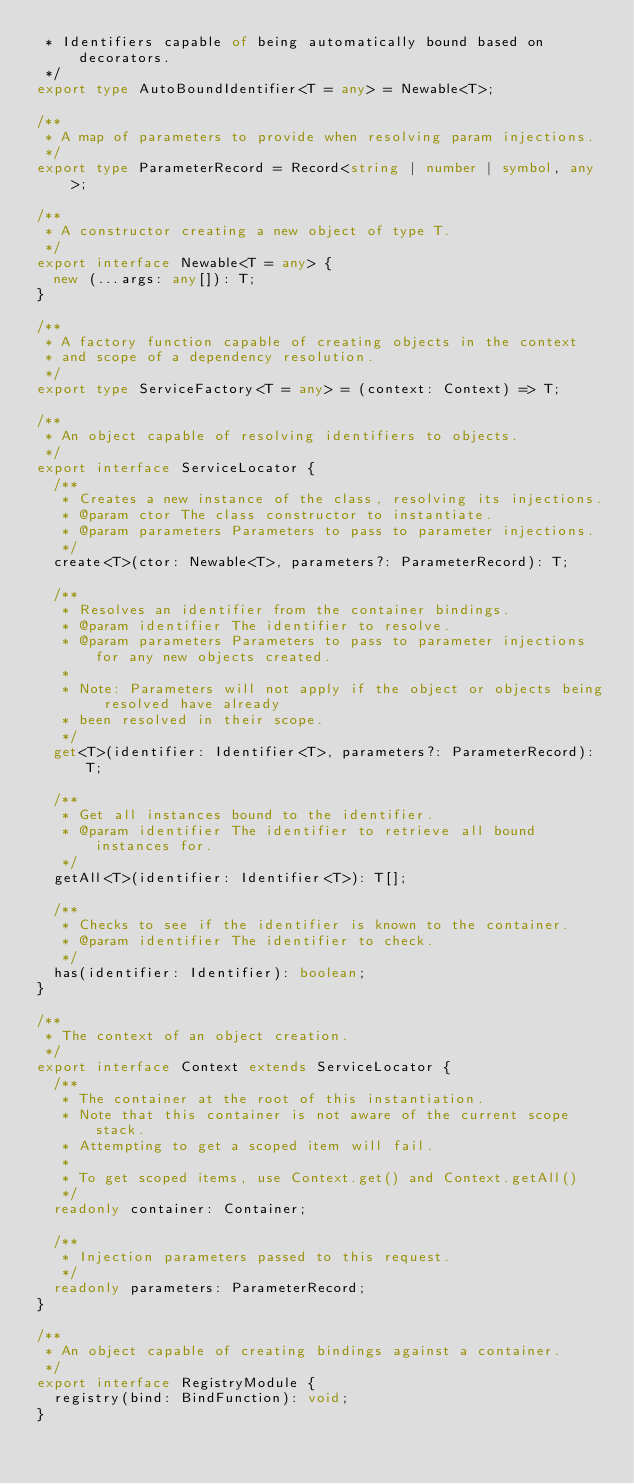<code> <loc_0><loc_0><loc_500><loc_500><_TypeScript_> * Identifiers capable of being automatically bound based on decorators.
 */
export type AutoBoundIdentifier<T = any> = Newable<T>;

/**
 * A map of parameters to provide when resolving param injections.
 */
export type ParameterRecord = Record<string | number | symbol, any>;

/**
 * A constructor creating a new object of type T.
 */
export interface Newable<T = any> {
  new (...args: any[]): T;
}

/**
 * A factory function capable of creating objects in the context
 * and scope of a dependency resolution.
 */
export type ServiceFactory<T = any> = (context: Context) => T;

/**
 * An object capable of resolving identifiers to objects.
 */
export interface ServiceLocator {
  /**
   * Creates a new instance of the class, resolving its injections.
   * @param ctor The class constructor to instantiate.
   * @param parameters Parameters to pass to parameter injections.
   */
  create<T>(ctor: Newable<T>, parameters?: ParameterRecord): T;

  /**
   * Resolves an identifier from the container bindings.
   * @param identifier The identifier to resolve.
   * @param parameters Parameters to pass to parameter injections for any new objects created.
   *
   * Note: Parameters will not apply if the object or objects being resolved have already
   * been resolved in their scope.
   */
  get<T>(identifier: Identifier<T>, parameters?: ParameterRecord): T;

  /**
   * Get all instances bound to the identifier.
   * @param identifier The identifier to retrieve all bound instances for.
   */
  getAll<T>(identifier: Identifier<T>): T[];

  /**
   * Checks to see if the identifier is known to the container.
   * @param identifier The identifier to check.
   */
  has(identifier: Identifier): boolean;
}

/**
 * The context of an object creation.
 */
export interface Context extends ServiceLocator {
  /**
   * The container at the root of this instantiation.
   * Note that this container is not aware of the current scope stack.
   * Attempting to get a scoped item will fail.
   *
   * To get scoped items, use Context.get() and Context.getAll()
   */
  readonly container: Container;

  /**
   * Injection parameters passed to this request.
   */
  readonly parameters: ParameterRecord;
}

/**
 * An object capable of creating bindings against a container.
 */
export interface RegistryModule {
  registry(bind: BindFunction): void;
}
</code> 